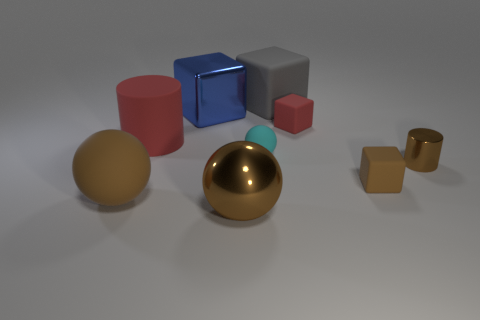Is the number of cylinders behind the tiny cyan matte ball less than the number of rubber objects that are in front of the small brown cylinder? Yes, there are fewer cylinders behind the tiny cyan matte ball than there are rubber objects in front of the small brown cylinder. Specifically, there is one cylinder behind the cyan ball and two rubber objects, a red cylinder and a red cube, in front of the brown cylinder. 